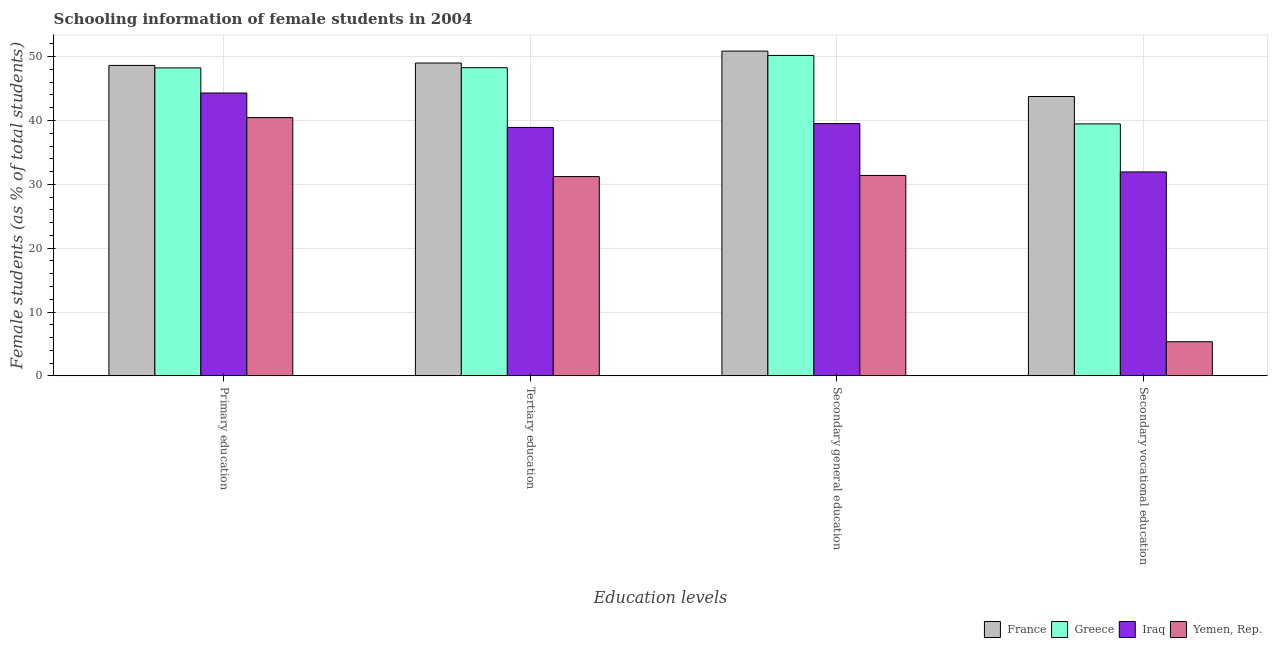How many different coloured bars are there?
Provide a short and direct response. 4. How many groups of bars are there?
Keep it short and to the point. 4. How many bars are there on the 1st tick from the right?
Make the answer very short. 4. What is the label of the 2nd group of bars from the left?
Your answer should be very brief. Tertiary education. What is the percentage of female students in secondary vocational education in Yemen, Rep.?
Provide a succinct answer. 5.35. Across all countries, what is the maximum percentage of female students in secondary education?
Provide a succinct answer. 50.87. Across all countries, what is the minimum percentage of female students in tertiary education?
Give a very brief answer. 31.22. In which country was the percentage of female students in tertiary education maximum?
Make the answer very short. France. In which country was the percentage of female students in tertiary education minimum?
Your answer should be compact. Yemen, Rep. What is the total percentage of female students in secondary vocational education in the graph?
Ensure brevity in your answer.  120.51. What is the difference between the percentage of female students in primary education in Iraq and that in France?
Offer a very short reply. -4.32. What is the difference between the percentage of female students in tertiary education in Yemen, Rep. and the percentage of female students in secondary education in France?
Provide a short and direct response. -19.65. What is the average percentage of female students in primary education per country?
Your answer should be compact. 45.41. What is the difference between the percentage of female students in tertiary education and percentage of female students in primary education in France?
Provide a succinct answer. 0.38. What is the ratio of the percentage of female students in secondary education in Greece to that in Yemen, Rep.?
Your response must be concise. 1.6. Is the percentage of female students in secondary vocational education in Yemen, Rep. less than that in Greece?
Ensure brevity in your answer.  Yes. What is the difference between the highest and the second highest percentage of female students in primary education?
Provide a short and direct response. 0.38. What is the difference between the highest and the lowest percentage of female students in secondary vocational education?
Offer a terse response. 38.41. Is it the case that in every country, the sum of the percentage of female students in primary education and percentage of female students in secondary education is greater than the sum of percentage of female students in tertiary education and percentage of female students in secondary vocational education?
Offer a very short reply. No. What does the 1st bar from the right in Tertiary education represents?
Offer a terse response. Yemen, Rep. How many countries are there in the graph?
Provide a succinct answer. 4. What is the difference between two consecutive major ticks on the Y-axis?
Your answer should be compact. 10. Does the graph contain any zero values?
Give a very brief answer. No. Where does the legend appear in the graph?
Give a very brief answer. Bottom right. How many legend labels are there?
Give a very brief answer. 4. What is the title of the graph?
Your response must be concise. Schooling information of female students in 2004. Does "Timor-Leste" appear as one of the legend labels in the graph?
Provide a succinct answer. No. What is the label or title of the X-axis?
Provide a succinct answer. Education levels. What is the label or title of the Y-axis?
Make the answer very short. Female students (as % of total students). What is the Female students (as % of total students) of France in Primary education?
Your response must be concise. 48.62. What is the Female students (as % of total students) of Greece in Primary education?
Provide a succinct answer. 48.24. What is the Female students (as % of total students) of Iraq in Primary education?
Your answer should be very brief. 44.3. What is the Female students (as % of total students) in Yemen, Rep. in Primary education?
Offer a terse response. 40.45. What is the Female students (as % of total students) in France in Tertiary education?
Offer a very short reply. 49. What is the Female students (as % of total students) of Greece in Tertiary education?
Keep it short and to the point. 48.27. What is the Female students (as % of total students) of Iraq in Tertiary education?
Offer a very short reply. 38.91. What is the Female students (as % of total students) in Yemen, Rep. in Tertiary education?
Provide a succinct answer. 31.22. What is the Female students (as % of total students) of France in Secondary general education?
Your answer should be compact. 50.87. What is the Female students (as % of total students) in Greece in Secondary general education?
Offer a terse response. 50.19. What is the Female students (as % of total students) of Iraq in Secondary general education?
Keep it short and to the point. 39.51. What is the Female students (as % of total students) of Yemen, Rep. in Secondary general education?
Offer a terse response. 31.39. What is the Female students (as % of total students) of France in Secondary vocational education?
Keep it short and to the point. 43.75. What is the Female students (as % of total students) of Greece in Secondary vocational education?
Your answer should be very brief. 39.46. What is the Female students (as % of total students) of Iraq in Secondary vocational education?
Your answer should be compact. 31.94. What is the Female students (as % of total students) of Yemen, Rep. in Secondary vocational education?
Your answer should be compact. 5.35. Across all Education levels, what is the maximum Female students (as % of total students) in France?
Your answer should be very brief. 50.87. Across all Education levels, what is the maximum Female students (as % of total students) in Greece?
Your answer should be very brief. 50.19. Across all Education levels, what is the maximum Female students (as % of total students) of Iraq?
Make the answer very short. 44.3. Across all Education levels, what is the maximum Female students (as % of total students) in Yemen, Rep.?
Keep it short and to the point. 40.45. Across all Education levels, what is the minimum Female students (as % of total students) in France?
Offer a very short reply. 43.75. Across all Education levels, what is the minimum Female students (as % of total students) of Greece?
Your response must be concise. 39.46. Across all Education levels, what is the minimum Female students (as % of total students) of Iraq?
Offer a very short reply. 31.94. Across all Education levels, what is the minimum Female students (as % of total students) of Yemen, Rep.?
Give a very brief answer. 5.35. What is the total Female students (as % of total students) of France in the graph?
Keep it short and to the point. 192.24. What is the total Female students (as % of total students) in Greece in the graph?
Offer a very short reply. 186.17. What is the total Female students (as % of total students) in Iraq in the graph?
Your response must be concise. 154.67. What is the total Female students (as % of total students) in Yemen, Rep. in the graph?
Make the answer very short. 108.41. What is the difference between the Female students (as % of total students) of France in Primary education and that in Tertiary education?
Keep it short and to the point. -0.38. What is the difference between the Female students (as % of total students) in Greece in Primary education and that in Tertiary education?
Keep it short and to the point. -0.03. What is the difference between the Female students (as % of total students) in Iraq in Primary education and that in Tertiary education?
Your answer should be compact. 5.39. What is the difference between the Female students (as % of total students) in Yemen, Rep. in Primary education and that in Tertiary education?
Your answer should be compact. 9.24. What is the difference between the Female students (as % of total students) of France in Primary education and that in Secondary general education?
Make the answer very short. -2.24. What is the difference between the Female students (as % of total students) in Greece in Primary education and that in Secondary general education?
Make the answer very short. -1.95. What is the difference between the Female students (as % of total students) of Iraq in Primary education and that in Secondary general education?
Your answer should be very brief. 4.79. What is the difference between the Female students (as % of total students) of Yemen, Rep. in Primary education and that in Secondary general education?
Offer a terse response. 9.07. What is the difference between the Female students (as % of total students) of France in Primary education and that in Secondary vocational education?
Your response must be concise. 4.87. What is the difference between the Female students (as % of total students) in Greece in Primary education and that in Secondary vocational education?
Keep it short and to the point. 8.78. What is the difference between the Female students (as % of total students) in Iraq in Primary education and that in Secondary vocational education?
Offer a very short reply. 12.36. What is the difference between the Female students (as % of total students) in Yemen, Rep. in Primary education and that in Secondary vocational education?
Provide a succinct answer. 35.11. What is the difference between the Female students (as % of total students) of France in Tertiary education and that in Secondary general education?
Offer a terse response. -1.87. What is the difference between the Female students (as % of total students) in Greece in Tertiary education and that in Secondary general education?
Your answer should be compact. -1.92. What is the difference between the Female students (as % of total students) of Iraq in Tertiary education and that in Secondary general education?
Your answer should be compact. -0.6. What is the difference between the Female students (as % of total students) in Yemen, Rep. in Tertiary education and that in Secondary general education?
Make the answer very short. -0.17. What is the difference between the Female students (as % of total students) in France in Tertiary education and that in Secondary vocational education?
Your answer should be compact. 5.25. What is the difference between the Female students (as % of total students) of Greece in Tertiary education and that in Secondary vocational education?
Provide a succinct answer. 8.81. What is the difference between the Female students (as % of total students) of Iraq in Tertiary education and that in Secondary vocational education?
Ensure brevity in your answer.  6.97. What is the difference between the Female students (as % of total students) in Yemen, Rep. in Tertiary education and that in Secondary vocational education?
Offer a terse response. 25.87. What is the difference between the Female students (as % of total students) of France in Secondary general education and that in Secondary vocational education?
Ensure brevity in your answer.  7.11. What is the difference between the Female students (as % of total students) in Greece in Secondary general education and that in Secondary vocational education?
Offer a very short reply. 10.73. What is the difference between the Female students (as % of total students) in Iraq in Secondary general education and that in Secondary vocational education?
Provide a short and direct response. 7.57. What is the difference between the Female students (as % of total students) in Yemen, Rep. in Secondary general education and that in Secondary vocational education?
Your response must be concise. 26.04. What is the difference between the Female students (as % of total students) in France in Primary education and the Female students (as % of total students) in Greece in Tertiary education?
Ensure brevity in your answer.  0.35. What is the difference between the Female students (as % of total students) of France in Primary education and the Female students (as % of total students) of Iraq in Tertiary education?
Offer a very short reply. 9.71. What is the difference between the Female students (as % of total students) in France in Primary education and the Female students (as % of total students) in Yemen, Rep. in Tertiary education?
Your answer should be compact. 17.4. What is the difference between the Female students (as % of total students) in Greece in Primary education and the Female students (as % of total students) in Iraq in Tertiary education?
Your response must be concise. 9.33. What is the difference between the Female students (as % of total students) in Greece in Primary education and the Female students (as % of total students) in Yemen, Rep. in Tertiary education?
Make the answer very short. 17.02. What is the difference between the Female students (as % of total students) of Iraq in Primary education and the Female students (as % of total students) of Yemen, Rep. in Tertiary education?
Provide a short and direct response. 13.09. What is the difference between the Female students (as % of total students) of France in Primary education and the Female students (as % of total students) of Greece in Secondary general education?
Give a very brief answer. -1.57. What is the difference between the Female students (as % of total students) of France in Primary education and the Female students (as % of total students) of Iraq in Secondary general education?
Offer a terse response. 9.11. What is the difference between the Female students (as % of total students) in France in Primary education and the Female students (as % of total students) in Yemen, Rep. in Secondary general education?
Provide a short and direct response. 17.23. What is the difference between the Female students (as % of total students) of Greece in Primary education and the Female students (as % of total students) of Iraq in Secondary general education?
Offer a very short reply. 8.73. What is the difference between the Female students (as % of total students) in Greece in Primary education and the Female students (as % of total students) in Yemen, Rep. in Secondary general education?
Offer a terse response. 16.85. What is the difference between the Female students (as % of total students) of Iraq in Primary education and the Female students (as % of total students) of Yemen, Rep. in Secondary general education?
Your answer should be very brief. 12.92. What is the difference between the Female students (as % of total students) in France in Primary education and the Female students (as % of total students) in Greece in Secondary vocational education?
Provide a succinct answer. 9.16. What is the difference between the Female students (as % of total students) in France in Primary education and the Female students (as % of total students) in Iraq in Secondary vocational education?
Offer a very short reply. 16.68. What is the difference between the Female students (as % of total students) of France in Primary education and the Female students (as % of total students) of Yemen, Rep. in Secondary vocational education?
Keep it short and to the point. 43.27. What is the difference between the Female students (as % of total students) of Greece in Primary education and the Female students (as % of total students) of Iraq in Secondary vocational education?
Your answer should be very brief. 16.3. What is the difference between the Female students (as % of total students) in Greece in Primary education and the Female students (as % of total students) in Yemen, Rep. in Secondary vocational education?
Give a very brief answer. 42.89. What is the difference between the Female students (as % of total students) of Iraq in Primary education and the Female students (as % of total students) of Yemen, Rep. in Secondary vocational education?
Your answer should be compact. 38.96. What is the difference between the Female students (as % of total students) of France in Tertiary education and the Female students (as % of total students) of Greece in Secondary general education?
Make the answer very short. -1.19. What is the difference between the Female students (as % of total students) in France in Tertiary education and the Female students (as % of total students) in Iraq in Secondary general education?
Offer a very short reply. 9.49. What is the difference between the Female students (as % of total students) of France in Tertiary education and the Female students (as % of total students) of Yemen, Rep. in Secondary general education?
Your answer should be compact. 17.61. What is the difference between the Female students (as % of total students) of Greece in Tertiary education and the Female students (as % of total students) of Iraq in Secondary general education?
Your answer should be very brief. 8.76. What is the difference between the Female students (as % of total students) of Greece in Tertiary education and the Female students (as % of total students) of Yemen, Rep. in Secondary general education?
Offer a terse response. 16.88. What is the difference between the Female students (as % of total students) in Iraq in Tertiary education and the Female students (as % of total students) in Yemen, Rep. in Secondary general education?
Provide a succinct answer. 7.52. What is the difference between the Female students (as % of total students) of France in Tertiary education and the Female students (as % of total students) of Greece in Secondary vocational education?
Offer a very short reply. 9.54. What is the difference between the Female students (as % of total students) in France in Tertiary education and the Female students (as % of total students) in Iraq in Secondary vocational education?
Provide a succinct answer. 17.06. What is the difference between the Female students (as % of total students) of France in Tertiary education and the Female students (as % of total students) of Yemen, Rep. in Secondary vocational education?
Your response must be concise. 43.65. What is the difference between the Female students (as % of total students) in Greece in Tertiary education and the Female students (as % of total students) in Iraq in Secondary vocational education?
Keep it short and to the point. 16.33. What is the difference between the Female students (as % of total students) in Greece in Tertiary education and the Female students (as % of total students) in Yemen, Rep. in Secondary vocational education?
Your response must be concise. 42.92. What is the difference between the Female students (as % of total students) of Iraq in Tertiary education and the Female students (as % of total students) of Yemen, Rep. in Secondary vocational education?
Your answer should be compact. 33.56. What is the difference between the Female students (as % of total students) in France in Secondary general education and the Female students (as % of total students) in Greece in Secondary vocational education?
Offer a terse response. 11.4. What is the difference between the Female students (as % of total students) in France in Secondary general education and the Female students (as % of total students) in Iraq in Secondary vocational education?
Keep it short and to the point. 18.92. What is the difference between the Female students (as % of total students) in France in Secondary general education and the Female students (as % of total students) in Yemen, Rep. in Secondary vocational education?
Offer a very short reply. 45.52. What is the difference between the Female students (as % of total students) of Greece in Secondary general education and the Female students (as % of total students) of Iraq in Secondary vocational education?
Provide a short and direct response. 18.25. What is the difference between the Female students (as % of total students) in Greece in Secondary general education and the Female students (as % of total students) in Yemen, Rep. in Secondary vocational education?
Offer a terse response. 44.84. What is the difference between the Female students (as % of total students) of Iraq in Secondary general education and the Female students (as % of total students) of Yemen, Rep. in Secondary vocational education?
Keep it short and to the point. 34.16. What is the average Female students (as % of total students) in France per Education levels?
Ensure brevity in your answer.  48.06. What is the average Female students (as % of total students) in Greece per Education levels?
Make the answer very short. 46.54. What is the average Female students (as % of total students) in Iraq per Education levels?
Provide a short and direct response. 38.67. What is the average Female students (as % of total students) in Yemen, Rep. per Education levels?
Provide a succinct answer. 27.1. What is the difference between the Female students (as % of total students) in France and Female students (as % of total students) in Greece in Primary education?
Provide a succinct answer. 0.38. What is the difference between the Female students (as % of total students) in France and Female students (as % of total students) in Iraq in Primary education?
Provide a short and direct response. 4.32. What is the difference between the Female students (as % of total students) in France and Female students (as % of total students) in Yemen, Rep. in Primary education?
Keep it short and to the point. 8.17. What is the difference between the Female students (as % of total students) of Greece and Female students (as % of total students) of Iraq in Primary education?
Make the answer very short. 3.94. What is the difference between the Female students (as % of total students) in Greece and Female students (as % of total students) in Yemen, Rep. in Primary education?
Ensure brevity in your answer.  7.79. What is the difference between the Female students (as % of total students) of Iraq and Female students (as % of total students) of Yemen, Rep. in Primary education?
Make the answer very short. 3.85. What is the difference between the Female students (as % of total students) in France and Female students (as % of total students) in Greece in Tertiary education?
Ensure brevity in your answer.  0.73. What is the difference between the Female students (as % of total students) in France and Female students (as % of total students) in Iraq in Tertiary education?
Give a very brief answer. 10.09. What is the difference between the Female students (as % of total students) in France and Female students (as % of total students) in Yemen, Rep. in Tertiary education?
Offer a very short reply. 17.78. What is the difference between the Female students (as % of total students) in Greece and Female students (as % of total students) in Iraq in Tertiary education?
Your response must be concise. 9.36. What is the difference between the Female students (as % of total students) in Greece and Female students (as % of total students) in Yemen, Rep. in Tertiary education?
Provide a succinct answer. 17.05. What is the difference between the Female students (as % of total students) in Iraq and Female students (as % of total students) in Yemen, Rep. in Tertiary education?
Offer a terse response. 7.69. What is the difference between the Female students (as % of total students) in France and Female students (as % of total students) in Greece in Secondary general education?
Keep it short and to the point. 0.67. What is the difference between the Female students (as % of total students) in France and Female students (as % of total students) in Iraq in Secondary general education?
Your answer should be very brief. 11.35. What is the difference between the Female students (as % of total students) of France and Female students (as % of total students) of Yemen, Rep. in Secondary general education?
Give a very brief answer. 19.48. What is the difference between the Female students (as % of total students) in Greece and Female students (as % of total students) in Iraq in Secondary general education?
Provide a succinct answer. 10.68. What is the difference between the Female students (as % of total students) of Greece and Female students (as % of total students) of Yemen, Rep. in Secondary general education?
Offer a very short reply. 18.8. What is the difference between the Female students (as % of total students) in Iraq and Female students (as % of total students) in Yemen, Rep. in Secondary general education?
Ensure brevity in your answer.  8.12. What is the difference between the Female students (as % of total students) in France and Female students (as % of total students) in Greece in Secondary vocational education?
Keep it short and to the point. 4.29. What is the difference between the Female students (as % of total students) in France and Female students (as % of total students) in Iraq in Secondary vocational education?
Provide a succinct answer. 11.81. What is the difference between the Female students (as % of total students) in France and Female students (as % of total students) in Yemen, Rep. in Secondary vocational education?
Keep it short and to the point. 38.41. What is the difference between the Female students (as % of total students) in Greece and Female students (as % of total students) in Iraq in Secondary vocational education?
Offer a very short reply. 7.52. What is the difference between the Female students (as % of total students) of Greece and Female students (as % of total students) of Yemen, Rep. in Secondary vocational education?
Provide a succinct answer. 34.12. What is the difference between the Female students (as % of total students) in Iraq and Female students (as % of total students) in Yemen, Rep. in Secondary vocational education?
Your response must be concise. 26.59. What is the ratio of the Female students (as % of total students) of Iraq in Primary education to that in Tertiary education?
Your response must be concise. 1.14. What is the ratio of the Female students (as % of total students) of Yemen, Rep. in Primary education to that in Tertiary education?
Your response must be concise. 1.3. What is the ratio of the Female students (as % of total students) of France in Primary education to that in Secondary general education?
Offer a very short reply. 0.96. What is the ratio of the Female students (as % of total students) of Greece in Primary education to that in Secondary general education?
Make the answer very short. 0.96. What is the ratio of the Female students (as % of total students) of Iraq in Primary education to that in Secondary general education?
Offer a very short reply. 1.12. What is the ratio of the Female students (as % of total students) of Yemen, Rep. in Primary education to that in Secondary general education?
Your response must be concise. 1.29. What is the ratio of the Female students (as % of total students) of France in Primary education to that in Secondary vocational education?
Offer a very short reply. 1.11. What is the ratio of the Female students (as % of total students) in Greece in Primary education to that in Secondary vocational education?
Your answer should be very brief. 1.22. What is the ratio of the Female students (as % of total students) in Iraq in Primary education to that in Secondary vocational education?
Provide a succinct answer. 1.39. What is the ratio of the Female students (as % of total students) of Yemen, Rep. in Primary education to that in Secondary vocational education?
Ensure brevity in your answer.  7.56. What is the ratio of the Female students (as % of total students) of France in Tertiary education to that in Secondary general education?
Offer a terse response. 0.96. What is the ratio of the Female students (as % of total students) of Greece in Tertiary education to that in Secondary general education?
Offer a terse response. 0.96. What is the ratio of the Female students (as % of total students) of France in Tertiary education to that in Secondary vocational education?
Provide a short and direct response. 1.12. What is the ratio of the Female students (as % of total students) in Greece in Tertiary education to that in Secondary vocational education?
Your answer should be compact. 1.22. What is the ratio of the Female students (as % of total students) of Iraq in Tertiary education to that in Secondary vocational education?
Your answer should be compact. 1.22. What is the ratio of the Female students (as % of total students) of Yemen, Rep. in Tertiary education to that in Secondary vocational education?
Make the answer very short. 5.84. What is the ratio of the Female students (as % of total students) of France in Secondary general education to that in Secondary vocational education?
Your answer should be very brief. 1.16. What is the ratio of the Female students (as % of total students) of Greece in Secondary general education to that in Secondary vocational education?
Your answer should be very brief. 1.27. What is the ratio of the Female students (as % of total students) in Iraq in Secondary general education to that in Secondary vocational education?
Make the answer very short. 1.24. What is the ratio of the Female students (as % of total students) of Yemen, Rep. in Secondary general education to that in Secondary vocational education?
Offer a terse response. 5.87. What is the difference between the highest and the second highest Female students (as % of total students) of France?
Give a very brief answer. 1.87. What is the difference between the highest and the second highest Female students (as % of total students) of Greece?
Make the answer very short. 1.92. What is the difference between the highest and the second highest Female students (as % of total students) in Iraq?
Make the answer very short. 4.79. What is the difference between the highest and the second highest Female students (as % of total students) of Yemen, Rep.?
Your response must be concise. 9.07. What is the difference between the highest and the lowest Female students (as % of total students) in France?
Make the answer very short. 7.11. What is the difference between the highest and the lowest Female students (as % of total students) in Greece?
Provide a succinct answer. 10.73. What is the difference between the highest and the lowest Female students (as % of total students) of Iraq?
Make the answer very short. 12.36. What is the difference between the highest and the lowest Female students (as % of total students) in Yemen, Rep.?
Your answer should be compact. 35.11. 